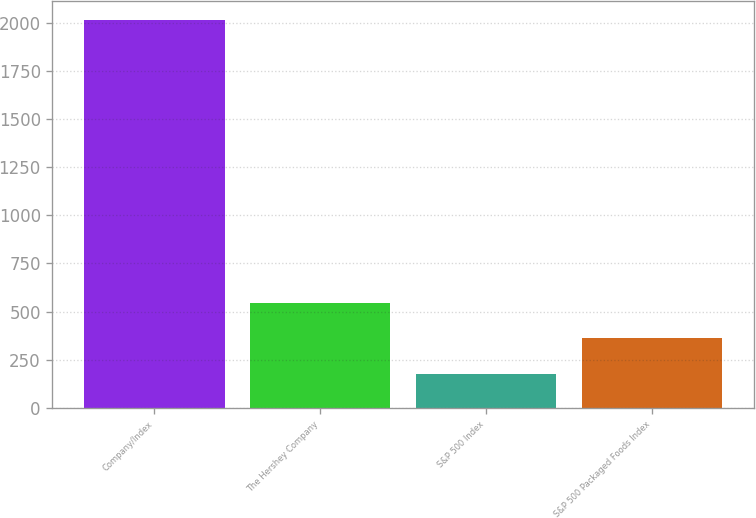Convert chart. <chart><loc_0><loc_0><loc_500><loc_500><bar_chart><fcel>Company/Index<fcel>The Hershey Company<fcel>S&P 500 Index<fcel>S&P 500 Packaged Foods Index<nl><fcel>2014<fcel>545.2<fcel>178<fcel>361.6<nl></chart> 